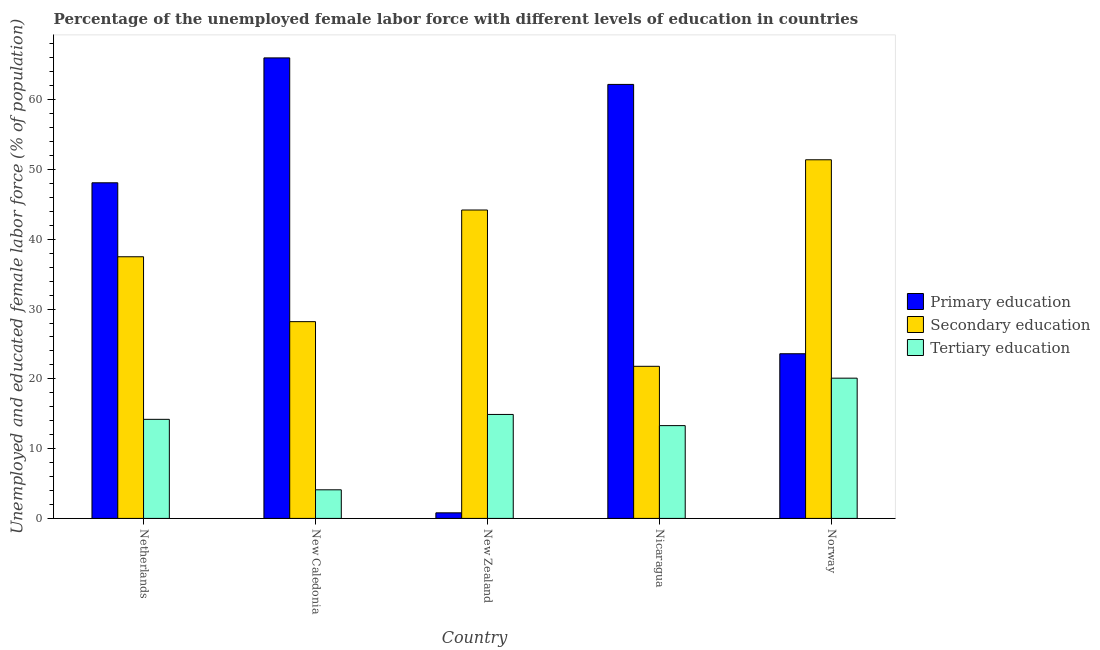How many different coloured bars are there?
Your answer should be very brief. 3. How many bars are there on the 3rd tick from the left?
Give a very brief answer. 3. How many bars are there on the 5th tick from the right?
Provide a succinct answer. 3. In how many cases, is the number of bars for a given country not equal to the number of legend labels?
Your response must be concise. 0. What is the percentage of female labor force who received secondary education in Netherlands?
Make the answer very short. 37.5. Across all countries, what is the maximum percentage of female labor force who received primary education?
Your answer should be very brief. 66. Across all countries, what is the minimum percentage of female labor force who received primary education?
Give a very brief answer. 0.8. In which country was the percentage of female labor force who received primary education minimum?
Give a very brief answer. New Zealand. What is the total percentage of female labor force who received secondary education in the graph?
Your answer should be very brief. 183.1. What is the difference between the percentage of female labor force who received secondary education in New Caledonia and that in Norway?
Offer a terse response. -23.2. What is the difference between the percentage of female labor force who received primary education in Norway and the percentage of female labor force who received tertiary education in New Caledonia?
Ensure brevity in your answer.  19.5. What is the average percentage of female labor force who received primary education per country?
Ensure brevity in your answer.  40.14. What is the difference between the percentage of female labor force who received tertiary education and percentage of female labor force who received primary education in New Zealand?
Make the answer very short. 14.1. What is the ratio of the percentage of female labor force who received secondary education in Netherlands to that in New Zealand?
Make the answer very short. 0.85. What is the difference between the highest and the second highest percentage of female labor force who received primary education?
Your response must be concise. 3.8. What is the difference between the highest and the lowest percentage of female labor force who received tertiary education?
Provide a succinct answer. 16. In how many countries, is the percentage of female labor force who received tertiary education greater than the average percentage of female labor force who received tertiary education taken over all countries?
Your answer should be compact. 3. Is the sum of the percentage of female labor force who received primary education in New Caledonia and New Zealand greater than the maximum percentage of female labor force who received tertiary education across all countries?
Provide a short and direct response. Yes. What does the 2nd bar from the left in New Zealand represents?
Make the answer very short. Secondary education. What does the 3rd bar from the right in Nicaragua represents?
Offer a very short reply. Primary education. How many bars are there?
Keep it short and to the point. 15. How many countries are there in the graph?
Offer a very short reply. 5. What is the difference between two consecutive major ticks on the Y-axis?
Your response must be concise. 10. Are the values on the major ticks of Y-axis written in scientific E-notation?
Your response must be concise. No. Does the graph contain any zero values?
Your answer should be very brief. No. Does the graph contain grids?
Your answer should be compact. No. Where does the legend appear in the graph?
Provide a short and direct response. Center right. How many legend labels are there?
Ensure brevity in your answer.  3. What is the title of the graph?
Keep it short and to the point. Percentage of the unemployed female labor force with different levels of education in countries. What is the label or title of the Y-axis?
Ensure brevity in your answer.  Unemployed and educated female labor force (% of population). What is the Unemployed and educated female labor force (% of population) of Primary education in Netherlands?
Your answer should be very brief. 48.1. What is the Unemployed and educated female labor force (% of population) of Secondary education in Netherlands?
Provide a short and direct response. 37.5. What is the Unemployed and educated female labor force (% of population) of Tertiary education in Netherlands?
Make the answer very short. 14.2. What is the Unemployed and educated female labor force (% of population) in Primary education in New Caledonia?
Offer a terse response. 66. What is the Unemployed and educated female labor force (% of population) in Secondary education in New Caledonia?
Keep it short and to the point. 28.2. What is the Unemployed and educated female labor force (% of population) of Tertiary education in New Caledonia?
Provide a short and direct response. 4.1. What is the Unemployed and educated female labor force (% of population) in Primary education in New Zealand?
Keep it short and to the point. 0.8. What is the Unemployed and educated female labor force (% of population) of Secondary education in New Zealand?
Provide a succinct answer. 44.2. What is the Unemployed and educated female labor force (% of population) in Tertiary education in New Zealand?
Make the answer very short. 14.9. What is the Unemployed and educated female labor force (% of population) of Primary education in Nicaragua?
Give a very brief answer. 62.2. What is the Unemployed and educated female labor force (% of population) in Secondary education in Nicaragua?
Your answer should be very brief. 21.8. What is the Unemployed and educated female labor force (% of population) in Tertiary education in Nicaragua?
Your response must be concise. 13.3. What is the Unemployed and educated female labor force (% of population) in Primary education in Norway?
Give a very brief answer. 23.6. What is the Unemployed and educated female labor force (% of population) in Secondary education in Norway?
Your answer should be compact. 51.4. What is the Unemployed and educated female labor force (% of population) in Tertiary education in Norway?
Provide a short and direct response. 20.1. Across all countries, what is the maximum Unemployed and educated female labor force (% of population) in Primary education?
Provide a succinct answer. 66. Across all countries, what is the maximum Unemployed and educated female labor force (% of population) in Secondary education?
Provide a short and direct response. 51.4. Across all countries, what is the maximum Unemployed and educated female labor force (% of population) of Tertiary education?
Your response must be concise. 20.1. Across all countries, what is the minimum Unemployed and educated female labor force (% of population) in Primary education?
Provide a short and direct response. 0.8. Across all countries, what is the minimum Unemployed and educated female labor force (% of population) in Secondary education?
Your answer should be compact. 21.8. Across all countries, what is the minimum Unemployed and educated female labor force (% of population) in Tertiary education?
Offer a terse response. 4.1. What is the total Unemployed and educated female labor force (% of population) in Primary education in the graph?
Provide a succinct answer. 200.7. What is the total Unemployed and educated female labor force (% of population) in Secondary education in the graph?
Your response must be concise. 183.1. What is the total Unemployed and educated female labor force (% of population) of Tertiary education in the graph?
Keep it short and to the point. 66.6. What is the difference between the Unemployed and educated female labor force (% of population) in Primary education in Netherlands and that in New Caledonia?
Offer a very short reply. -17.9. What is the difference between the Unemployed and educated female labor force (% of population) in Primary education in Netherlands and that in New Zealand?
Keep it short and to the point. 47.3. What is the difference between the Unemployed and educated female labor force (% of population) in Tertiary education in Netherlands and that in New Zealand?
Your answer should be very brief. -0.7. What is the difference between the Unemployed and educated female labor force (% of population) of Primary education in Netherlands and that in Nicaragua?
Your answer should be very brief. -14.1. What is the difference between the Unemployed and educated female labor force (% of population) in Tertiary education in Netherlands and that in Nicaragua?
Your answer should be very brief. 0.9. What is the difference between the Unemployed and educated female labor force (% of population) in Secondary education in Netherlands and that in Norway?
Your response must be concise. -13.9. What is the difference between the Unemployed and educated female labor force (% of population) in Primary education in New Caledonia and that in New Zealand?
Ensure brevity in your answer.  65.2. What is the difference between the Unemployed and educated female labor force (% of population) in Primary education in New Caledonia and that in Nicaragua?
Ensure brevity in your answer.  3.8. What is the difference between the Unemployed and educated female labor force (% of population) of Secondary education in New Caledonia and that in Nicaragua?
Offer a terse response. 6.4. What is the difference between the Unemployed and educated female labor force (% of population) of Primary education in New Caledonia and that in Norway?
Your answer should be compact. 42.4. What is the difference between the Unemployed and educated female labor force (% of population) in Secondary education in New Caledonia and that in Norway?
Your answer should be very brief. -23.2. What is the difference between the Unemployed and educated female labor force (% of population) in Primary education in New Zealand and that in Nicaragua?
Provide a succinct answer. -61.4. What is the difference between the Unemployed and educated female labor force (% of population) in Secondary education in New Zealand and that in Nicaragua?
Keep it short and to the point. 22.4. What is the difference between the Unemployed and educated female labor force (% of population) of Primary education in New Zealand and that in Norway?
Make the answer very short. -22.8. What is the difference between the Unemployed and educated female labor force (% of population) in Tertiary education in New Zealand and that in Norway?
Your answer should be very brief. -5.2. What is the difference between the Unemployed and educated female labor force (% of population) of Primary education in Nicaragua and that in Norway?
Your answer should be compact. 38.6. What is the difference between the Unemployed and educated female labor force (% of population) in Secondary education in Nicaragua and that in Norway?
Keep it short and to the point. -29.6. What is the difference between the Unemployed and educated female labor force (% of population) in Tertiary education in Nicaragua and that in Norway?
Ensure brevity in your answer.  -6.8. What is the difference between the Unemployed and educated female labor force (% of population) in Primary education in Netherlands and the Unemployed and educated female labor force (% of population) in Secondary education in New Caledonia?
Your answer should be compact. 19.9. What is the difference between the Unemployed and educated female labor force (% of population) of Secondary education in Netherlands and the Unemployed and educated female labor force (% of population) of Tertiary education in New Caledonia?
Keep it short and to the point. 33.4. What is the difference between the Unemployed and educated female labor force (% of population) in Primary education in Netherlands and the Unemployed and educated female labor force (% of population) in Secondary education in New Zealand?
Your response must be concise. 3.9. What is the difference between the Unemployed and educated female labor force (% of population) in Primary education in Netherlands and the Unemployed and educated female labor force (% of population) in Tertiary education in New Zealand?
Your answer should be compact. 33.2. What is the difference between the Unemployed and educated female labor force (% of population) of Secondary education in Netherlands and the Unemployed and educated female labor force (% of population) of Tertiary education in New Zealand?
Your answer should be compact. 22.6. What is the difference between the Unemployed and educated female labor force (% of population) of Primary education in Netherlands and the Unemployed and educated female labor force (% of population) of Secondary education in Nicaragua?
Ensure brevity in your answer.  26.3. What is the difference between the Unemployed and educated female labor force (% of population) in Primary education in Netherlands and the Unemployed and educated female labor force (% of population) in Tertiary education in Nicaragua?
Your answer should be very brief. 34.8. What is the difference between the Unemployed and educated female labor force (% of population) of Secondary education in Netherlands and the Unemployed and educated female labor force (% of population) of Tertiary education in Nicaragua?
Your answer should be very brief. 24.2. What is the difference between the Unemployed and educated female labor force (% of population) of Primary education in Netherlands and the Unemployed and educated female labor force (% of population) of Secondary education in Norway?
Your answer should be very brief. -3.3. What is the difference between the Unemployed and educated female labor force (% of population) of Primary education in New Caledonia and the Unemployed and educated female labor force (% of population) of Secondary education in New Zealand?
Offer a very short reply. 21.8. What is the difference between the Unemployed and educated female labor force (% of population) in Primary education in New Caledonia and the Unemployed and educated female labor force (% of population) in Tertiary education in New Zealand?
Keep it short and to the point. 51.1. What is the difference between the Unemployed and educated female labor force (% of population) in Primary education in New Caledonia and the Unemployed and educated female labor force (% of population) in Secondary education in Nicaragua?
Give a very brief answer. 44.2. What is the difference between the Unemployed and educated female labor force (% of population) of Primary education in New Caledonia and the Unemployed and educated female labor force (% of population) of Tertiary education in Nicaragua?
Offer a terse response. 52.7. What is the difference between the Unemployed and educated female labor force (% of population) of Secondary education in New Caledonia and the Unemployed and educated female labor force (% of population) of Tertiary education in Nicaragua?
Your response must be concise. 14.9. What is the difference between the Unemployed and educated female labor force (% of population) of Primary education in New Caledonia and the Unemployed and educated female labor force (% of population) of Tertiary education in Norway?
Keep it short and to the point. 45.9. What is the difference between the Unemployed and educated female labor force (% of population) in Primary education in New Zealand and the Unemployed and educated female labor force (% of population) in Secondary education in Nicaragua?
Your answer should be very brief. -21. What is the difference between the Unemployed and educated female labor force (% of population) in Primary education in New Zealand and the Unemployed and educated female labor force (% of population) in Tertiary education in Nicaragua?
Your response must be concise. -12.5. What is the difference between the Unemployed and educated female labor force (% of population) in Secondary education in New Zealand and the Unemployed and educated female labor force (% of population) in Tertiary education in Nicaragua?
Provide a succinct answer. 30.9. What is the difference between the Unemployed and educated female labor force (% of population) of Primary education in New Zealand and the Unemployed and educated female labor force (% of population) of Secondary education in Norway?
Offer a terse response. -50.6. What is the difference between the Unemployed and educated female labor force (% of population) of Primary education in New Zealand and the Unemployed and educated female labor force (% of population) of Tertiary education in Norway?
Your answer should be compact. -19.3. What is the difference between the Unemployed and educated female labor force (% of population) of Secondary education in New Zealand and the Unemployed and educated female labor force (% of population) of Tertiary education in Norway?
Make the answer very short. 24.1. What is the difference between the Unemployed and educated female labor force (% of population) in Primary education in Nicaragua and the Unemployed and educated female labor force (% of population) in Secondary education in Norway?
Ensure brevity in your answer.  10.8. What is the difference between the Unemployed and educated female labor force (% of population) in Primary education in Nicaragua and the Unemployed and educated female labor force (% of population) in Tertiary education in Norway?
Your answer should be compact. 42.1. What is the difference between the Unemployed and educated female labor force (% of population) in Secondary education in Nicaragua and the Unemployed and educated female labor force (% of population) in Tertiary education in Norway?
Keep it short and to the point. 1.7. What is the average Unemployed and educated female labor force (% of population) of Primary education per country?
Your answer should be compact. 40.14. What is the average Unemployed and educated female labor force (% of population) of Secondary education per country?
Keep it short and to the point. 36.62. What is the average Unemployed and educated female labor force (% of population) in Tertiary education per country?
Offer a terse response. 13.32. What is the difference between the Unemployed and educated female labor force (% of population) of Primary education and Unemployed and educated female labor force (% of population) of Secondary education in Netherlands?
Provide a succinct answer. 10.6. What is the difference between the Unemployed and educated female labor force (% of population) in Primary education and Unemployed and educated female labor force (% of population) in Tertiary education in Netherlands?
Offer a very short reply. 33.9. What is the difference between the Unemployed and educated female labor force (% of population) in Secondary education and Unemployed and educated female labor force (% of population) in Tertiary education in Netherlands?
Provide a succinct answer. 23.3. What is the difference between the Unemployed and educated female labor force (% of population) of Primary education and Unemployed and educated female labor force (% of population) of Secondary education in New Caledonia?
Your answer should be compact. 37.8. What is the difference between the Unemployed and educated female labor force (% of population) in Primary education and Unemployed and educated female labor force (% of population) in Tertiary education in New Caledonia?
Your response must be concise. 61.9. What is the difference between the Unemployed and educated female labor force (% of population) of Secondary education and Unemployed and educated female labor force (% of population) of Tertiary education in New Caledonia?
Provide a short and direct response. 24.1. What is the difference between the Unemployed and educated female labor force (% of population) of Primary education and Unemployed and educated female labor force (% of population) of Secondary education in New Zealand?
Make the answer very short. -43.4. What is the difference between the Unemployed and educated female labor force (% of population) of Primary education and Unemployed and educated female labor force (% of population) of Tertiary education in New Zealand?
Make the answer very short. -14.1. What is the difference between the Unemployed and educated female labor force (% of population) of Secondary education and Unemployed and educated female labor force (% of population) of Tertiary education in New Zealand?
Provide a succinct answer. 29.3. What is the difference between the Unemployed and educated female labor force (% of population) in Primary education and Unemployed and educated female labor force (% of population) in Secondary education in Nicaragua?
Your response must be concise. 40.4. What is the difference between the Unemployed and educated female labor force (% of population) of Primary education and Unemployed and educated female labor force (% of population) of Tertiary education in Nicaragua?
Offer a very short reply. 48.9. What is the difference between the Unemployed and educated female labor force (% of population) of Primary education and Unemployed and educated female labor force (% of population) of Secondary education in Norway?
Give a very brief answer. -27.8. What is the difference between the Unemployed and educated female labor force (% of population) of Primary education and Unemployed and educated female labor force (% of population) of Tertiary education in Norway?
Offer a very short reply. 3.5. What is the difference between the Unemployed and educated female labor force (% of population) in Secondary education and Unemployed and educated female labor force (% of population) in Tertiary education in Norway?
Offer a terse response. 31.3. What is the ratio of the Unemployed and educated female labor force (% of population) of Primary education in Netherlands to that in New Caledonia?
Provide a succinct answer. 0.73. What is the ratio of the Unemployed and educated female labor force (% of population) in Secondary education in Netherlands to that in New Caledonia?
Your response must be concise. 1.33. What is the ratio of the Unemployed and educated female labor force (% of population) of Tertiary education in Netherlands to that in New Caledonia?
Keep it short and to the point. 3.46. What is the ratio of the Unemployed and educated female labor force (% of population) in Primary education in Netherlands to that in New Zealand?
Provide a short and direct response. 60.12. What is the ratio of the Unemployed and educated female labor force (% of population) in Secondary education in Netherlands to that in New Zealand?
Provide a short and direct response. 0.85. What is the ratio of the Unemployed and educated female labor force (% of population) of Tertiary education in Netherlands to that in New Zealand?
Keep it short and to the point. 0.95. What is the ratio of the Unemployed and educated female labor force (% of population) in Primary education in Netherlands to that in Nicaragua?
Give a very brief answer. 0.77. What is the ratio of the Unemployed and educated female labor force (% of population) in Secondary education in Netherlands to that in Nicaragua?
Ensure brevity in your answer.  1.72. What is the ratio of the Unemployed and educated female labor force (% of population) of Tertiary education in Netherlands to that in Nicaragua?
Your answer should be very brief. 1.07. What is the ratio of the Unemployed and educated female labor force (% of population) in Primary education in Netherlands to that in Norway?
Give a very brief answer. 2.04. What is the ratio of the Unemployed and educated female labor force (% of population) of Secondary education in Netherlands to that in Norway?
Your response must be concise. 0.73. What is the ratio of the Unemployed and educated female labor force (% of population) in Tertiary education in Netherlands to that in Norway?
Offer a very short reply. 0.71. What is the ratio of the Unemployed and educated female labor force (% of population) in Primary education in New Caledonia to that in New Zealand?
Keep it short and to the point. 82.5. What is the ratio of the Unemployed and educated female labor force (% of population) in Secondary education in New Caledonia to that in New Zealand?
Give a very brief answer. 0.64. What is the ratio of the Unemployed and educated female labor force (% of population) of Tertiary education in New Caledonia to that in New Zealand?
Keep it short and to the point. 0.28. What is the ratio of the Unemployed and educated female labor force (% of population) of Primary education in New Caledonia to that in Nicaragua?
Offer a very short reply. 1.06. What is the ratio of the Unemployed and educated female labor force (% of population) of Secondary education in New Caledonia to that in Nicaragua?
Provide a succinct answer. 1.29. What is the ratio of the Unemployed and educated female labor force (% of population) in Tertiary education in New Caledonia to that in Nicaragua?
Provide a succinct answer. 0.31. What is the ratio of the Unemployed and educated female labor force (% of population) in Primary education in New Caledonia to that in Norway?
Your answer should be compact. 2.8. What is the ratio of the Unemployed and educated female labor force (% of population) of Secondary education in New Caledonia to that in Norway?
Provide a succinct answer. 0.55. What is the ratio of the Unemployed and educated female labor force (% of population) in Tertiary education in New Caledonia to that in Norway?
Make the answer very short. 0.2. What is the ratio of the Unemployed and educated female labor force (% of population) in Primary education in New Zealand to that in Nicaragua?
Your answer should be very brief. 0.01. What is the ratio of the Unemployed and educated female labor force (% of population) in Secondary education in New Zealand to that in Nicaragua?
Keep it short and to the point. 2.03. What is the ratio of the Unemployed and educated female labor force (% of population) in Tertiary education in New Zealand to that in Nicaragua?
Your response must be concise. 1.12. What is the ratio of the Unemployed and educated female labor force (% of population) in Primary education in New Zealand to that in Norway?
Keep it short and to the point. 0.03. What is the ratio of the Unemployed and educated female labor force (% of population) of Secondary education in New Zealand to that in Norway?
Ensure brevity in your answer.  0.86. What is the ratio of the Unemployed and educated female labor force (% of population) in Tertiary education in New Zealand to that in Norway?
Give a very brief answer. 0.74. What is the ratio of the Unemployed and educated female labor force (% of population) in Primary education in Nicaragua to that in Norway?
Provide a short and direct response. 2.64. What is the ratio of the Unemployed and educated female labor force (% of population) in Secondary education in Nicaragua to that in Norway?
Make the answer very short. 0.42. What is the ratio of the Unemployed and educated female labor force (% of population) of Tertiary education in Nicaragua to that in Norway?
Your answer should be compact. 0.66. What is the difference between the highest and the second highest Unemployed and educated female labor force (% of population) of Tertiary education?
Ensure brevity in your answer.  5.2. What is the difference between the highest and the lowest Unemployed and educated female labor force (% of population) of Primary education?
Keep it short and to the point. 65.2. What is the difference between the highest and the lowest Unemployed and educated female labor force (% of population) in Secondary education?
Your answer should be very brief. 29.6. 